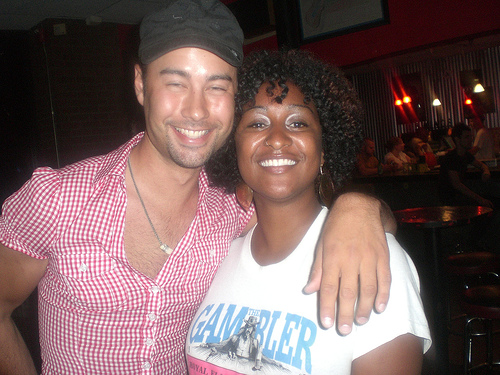<image>
Is there a hat on the woman? No. The hat is not positioned on the woman. They may be near each other, but the hat is not supported by or resting on top of the woman. 